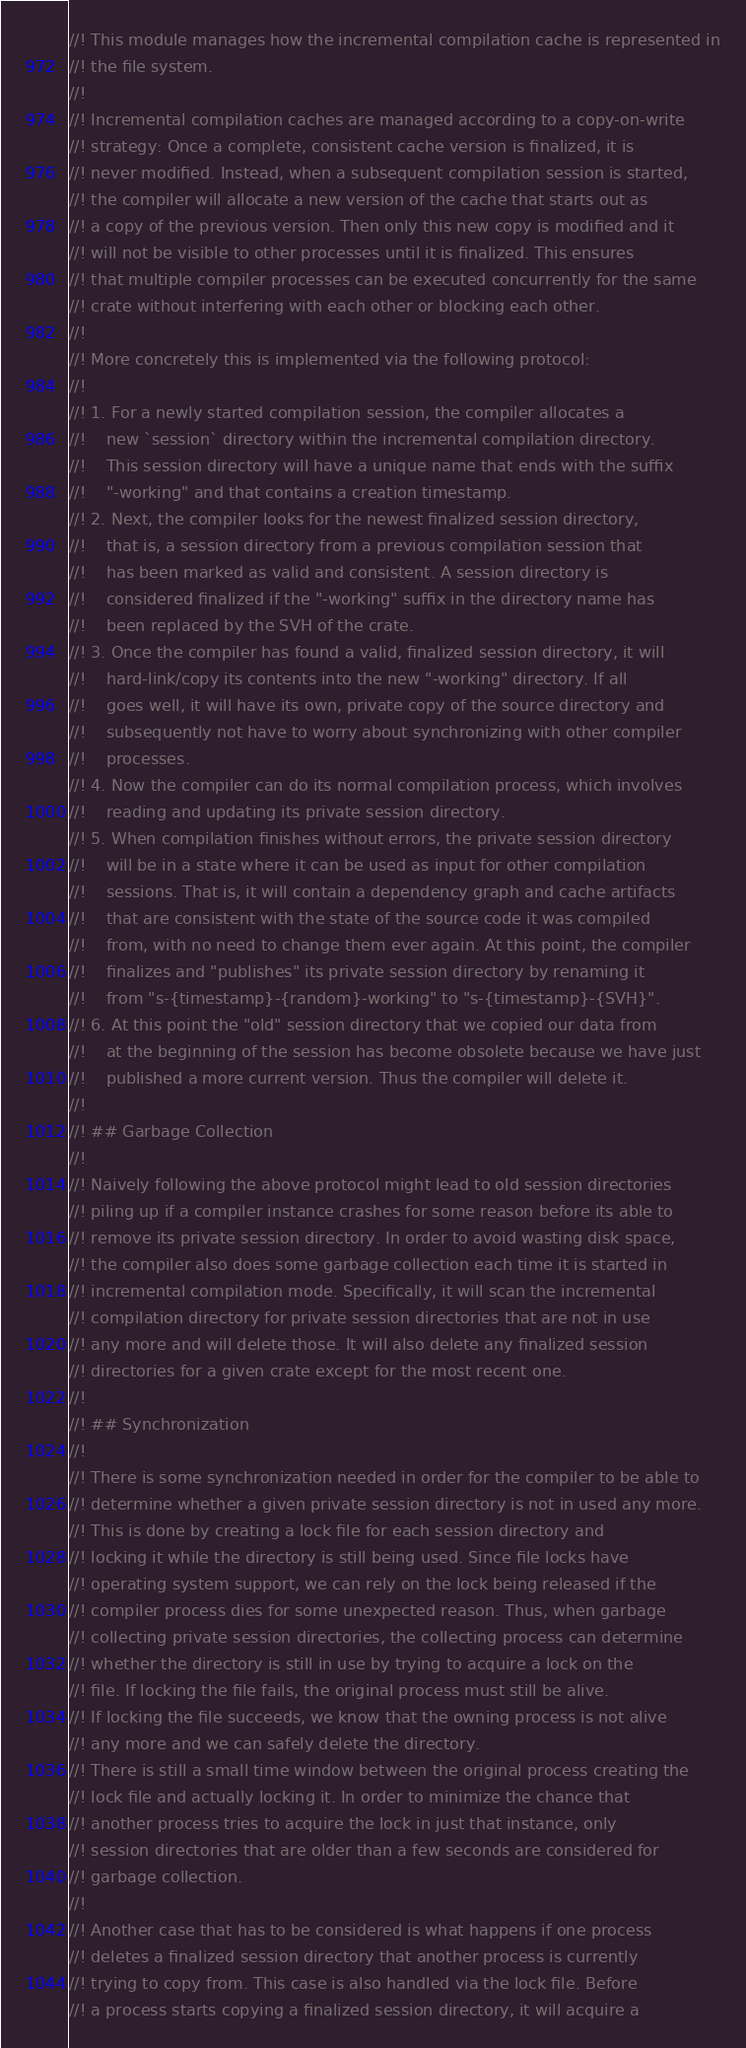<code> <loc_0><loc_0><loc_500><loc_500><_Rust_>//! This module manages how the incremental compilation cache is represented in
//! the file system.
//!
//! Incremental compilation caches are managed according to a copy-on-write
//! strategy: Once a complete, consistent cache version is finalized, it is
//! never modified. Instead, when a subsequent compilation session is started,
//! the compiler will allocate a new version of the cache that starts out as
//! a copy of the previous version. Then only this new copy is modified and it
//! will not be visible to other processes until it is finalized. This ensures
//! that multiple compiler processes can be executed concurrently for the same
//! crate without interfering with each other or blocking each other.
//!
//! More concretely this is implemented via the following protocol:
//!
//! 1. For a newly started compilation session, the compiler allocates a
//!    new `session` directory within the incremental compilation directory.
//!    This session directory will have a unique name that ends with the suffix
//!    "-working" and that contains a creation timestamp.
//! 2. Next, the compiler looks for the newest finalized session directory,
//!    that is, a session directory from a previous compilation session that
//!    has been marked as valid and consistent. A session directory is
//!    considered finalized if the "-working" suffix in the directory name has
//!    been replaced by the SVH of the crate.
//! 3. Once the compiler has found a valid, finalized session directory, it will
//!    hard-link/copy its contents into the new "-working" directory. If all
//!    goes well, it will have its own, private copy of the source directory and
//!    subsequently not have to worry about synchronizing with other compiler
//!    processes.
//! 4. Now the compiler can do its normal compilation process, which involves
//!    reading and updating its private session directory.
//! 5. When compilation finishes without errors, the private session directory
//!    will be in a state where it can be used as input for other compilation
//!    sessions. That is, it will contain a dependency graph and cache artifacts
//!    that are consistent with the state of the source code it was compiled
//!    from, with no need to change them ever again. At this point, the compiler
//!    finalizes and "publishes" its private session directory by renaming it
//!    from "s-{timestamp}-{random}-working" to "s-{timestamp}-{SVH}".
//! 6. At this point the "old" session directory that we copied our data from
//!    at the beginning of the session has become obsolete because we have just
//!    published a more current version. Thus the compiler will delete it.
//!
//! ## Garbage Collection
//!
//! Naively following the above protocol might lead to old session directories
//! piling up if a compiler instance crashes for some reason before its able to
//! remove its private session directory. In order to avoid wasting disk space,
//! the compiler also does some garbage collection each time it is started in
//! incremental compilation mode. Specifically, it will scan the incremental
//! compilation directory for private session directories that are not in use
//! any more and will delete those. It will also delete any finalized session
//! directories for a given crate except for the most recent one.
//!
//! ## Synchronization
//!
//! There is some synchronization needed in order for the compiler to be able to
//! determine whether a given private session directory is not in used any more.
//! This is done by creating a lock file for each session directory and
//! locking it while the directory is still being used. Since file locks have
//! operating system support, we can rely on the lock being released if the
//! compiler process dies for some unexpected reason. Thus, when garbage
//! collecting private session directories, the collecting process can determine
//! whether the directory is still in use by trying to acquire a lock on the
//! file. If locking the file fails, the original process must still be alive.
//! If locking the file succeeds, we know that the owning process is not alive
//! any more and we can safely delete the directory.
//! There is still a small time window between the original process creating the
//! lock file and actually locking it. In order to minimize the chance that
//! another process tries to acquire the lock in just that instance, only
//! session directories that are older than a few seconds are considered for
//! garbage collection.
//!
//! Another case that has to be considered is what happens if one process
//! deletes a finalized session directory that another process is currently
//! trying to copy from. This case is also handled via the lock file. Before
//! a process starts copying a finalized session directory, it will acquire a</code> 